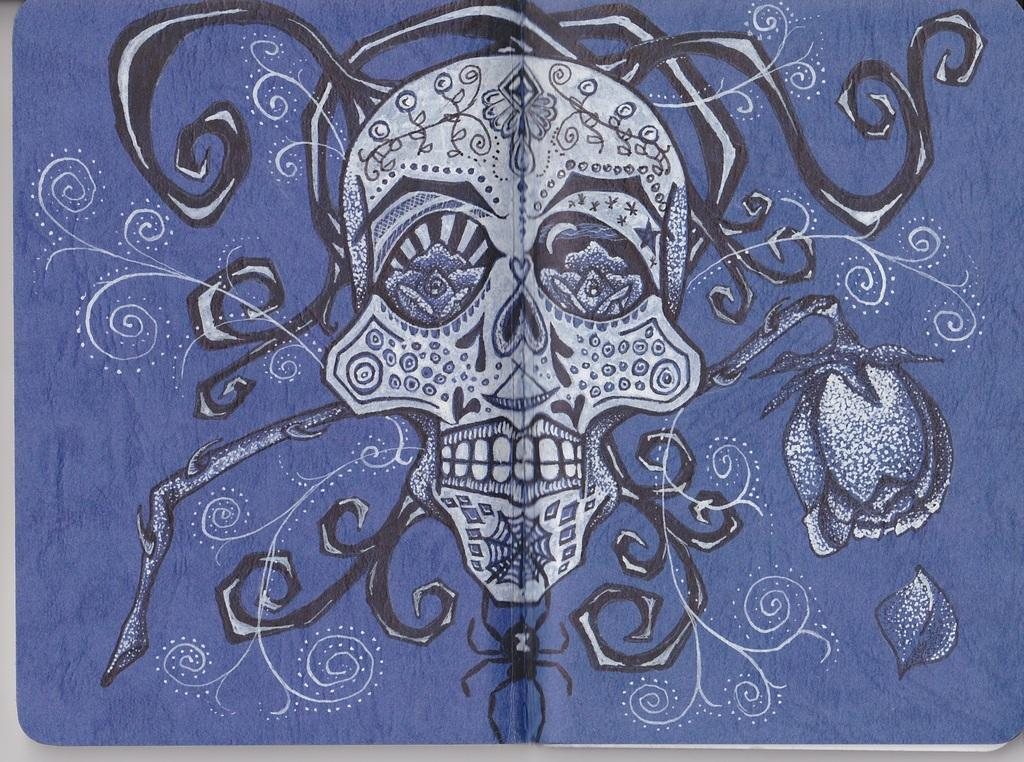What is depicted in the painting in the image? There is a painting of a skull in the image. What is the painting placed on? The painting is on a cloth. Can you describe the cloth in the image? The cloth has designs. How many brothers are depicted in the painting? There are no brothers depicted in the painting; it features a skull. What time is shown on the clock in the image? There is no clock present in the image. 